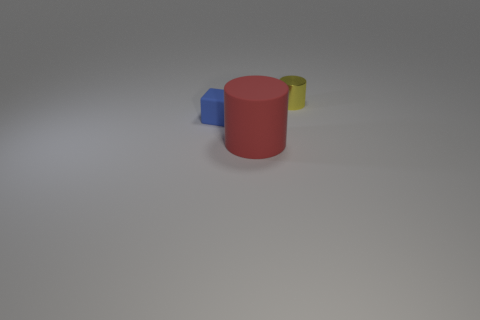Add 3 red objects. How many objects exist? 6 Subtract all cubes. How many objects are left? 2 Add 3 small yellow metallic things. How many small yellow metallic things exist? 4 Subtract 0 brown balls. How many objects are left? 3 Subtract all blue blocks. Subtract all red matte objects. How many objects are left? 1 Add 2 yellow things. How many yellow things are left? 3 